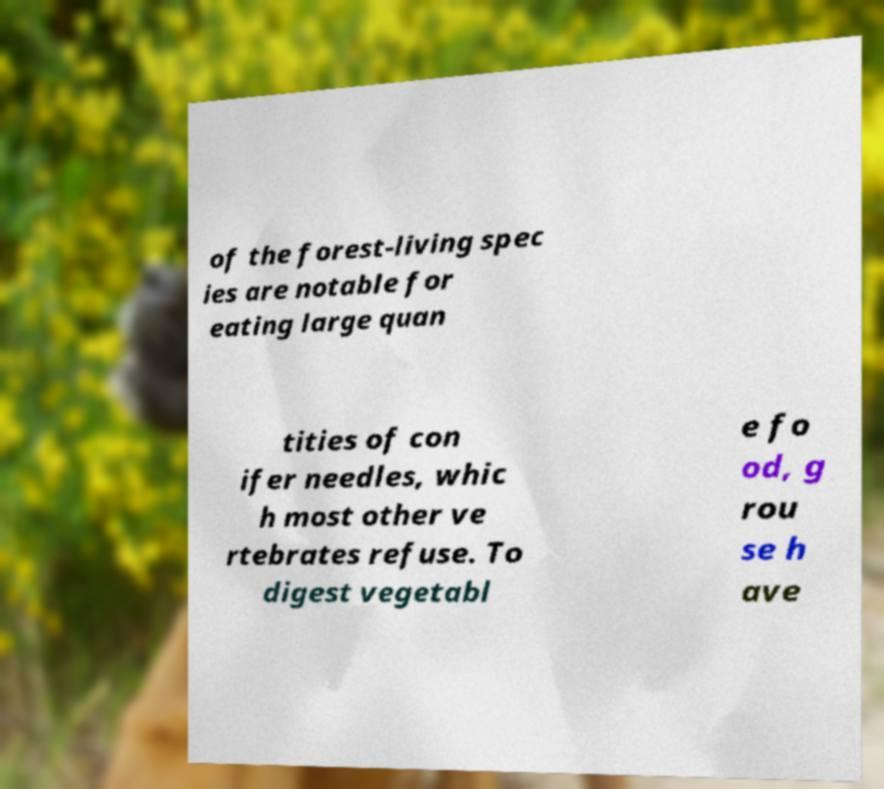Can you read and provide the text displayed in the image?This photo seems to have some interesting text. Can you extract and type it out for me? of the forest-living spec ies are notable for eating large quan tities of con ifer needles, whic h most other ve rtebrates refuse. To digest vegetabl e fo od, g rou se h ave 